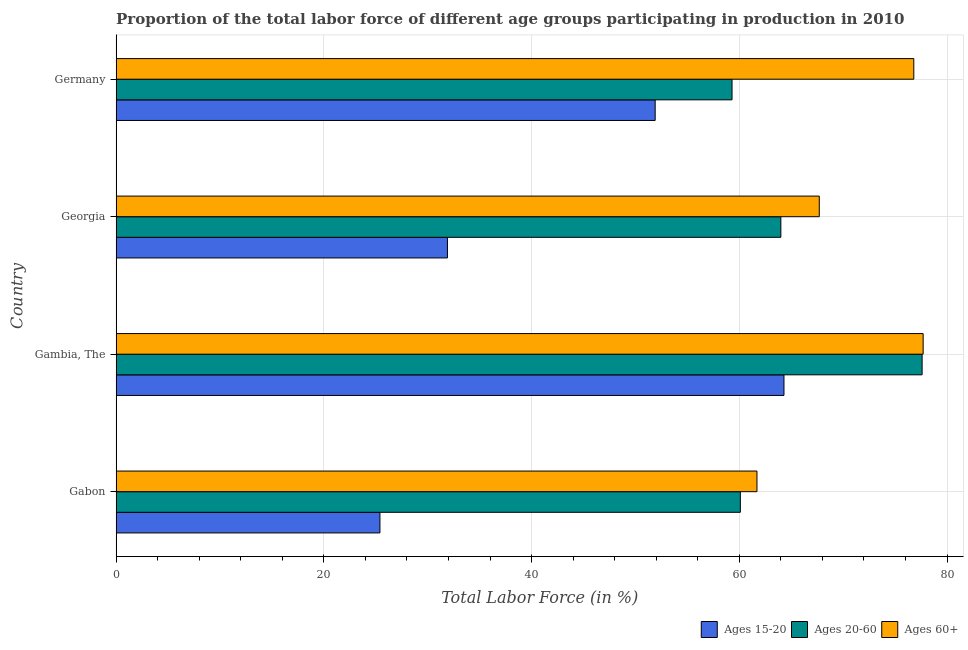How many different coloured bars are there?
Give a very brief answer. 3. How many groups of bars are there?
Keep it short and to the point. 4. Are the number of bars on each tick of the Y-axis equal?
Your answer should be compact. Yes. How many bars are there on the 4th tick from the top?
Give a very brief answer. 3. What is the label of the 2nd group of bars from the top?
Your answer should be very brief. Georgia. What is the percentage of labor force above age 60 in Georgia?
Offer a very short reply. 67.7. Across all countries, what is the maximum percentage of labor force within the age group 20-60?
Make the answer very short. 77.6. Across all countries, what is the minimum percentage of labor force within the age group 20-60?
Your response must be concise. 59.3. In which country was the percentage of labor force within the age group 20-60 maximum?
Your answer should be compact. Gambia, The. What is the total percentage of labor force within the age group 15-20 in the graph?
Your response must be concise. 173.5. What is the difference between the percentage of labor force within the age group 20-60 in Georgia and that in Germany?
Your answer should be very brief. 4.7. What is the difference between the percentage of labor force within the age group 15-20 in Gambia, The and the percentage of labor force within the age group 20-60 in Germany?
Your answer should be very brief. 5. What is the average percentage of labor force within the age group 20-60 per country?
Give a very brief answer. 65.25. What is the difference between the percentage of labor force within the age group 20-60 and percentage of labor force within the age group 15-20 in Georgia?
Keep it short and to the point. 32.1. In how many countries, is the percentage of labor force above age 60 greater than 64 %?
Offer a very short reply. 3. What is the ratio of the percentage of labor force within the age group 20-60 in Gabon to that in Georgia?
Provide a succinct answer. 0.94. Is the percentage of labor force within the age group 15-20 in Gambia, The less than that in Germany?
Provide a short and direct response. No. Is the difference between the percentage of labor force within the age group 15-20 in Gambia, The and Georgia greater than the difference between the percentage of labor force within the age group 20-60 in Gambia, The and Georgia?
Ensure brevity in your answer.  Yes. What is the difference between the highest and the lowest percentage of labor force within the age group 15-20?
Ensure brevity in your answer.  38.9. What does the 1st bar from the top in Germany represents?
Your response must be concise. Ages 60+. What does the 1st bar from the bottom in Gambia, The represents?
Ensure brevity in your answer.  Ages 15-20. Is it the case that in every country, the sum of the percentage of labor force within the age group 15-20 and percentage of labor force within the age group 20-60 is greater than the percentage of labor force above age 60?
Offer a very short reply. Yes. How many bars are there?
Your answer should be very brief. 12. How many countries are there in the graph?
Offer a very short reply. 4. Are the values on the major ticks of X-axis written in scientific E-notation?
Your answer should be compact. No. Does the graph contain any zero values?
Give a very brief answer. No. Does the graph contain grids?
Offer a terse response. Yes. How are the legend labels stacked?
Give a very brief answer. Horizontal. What is the title of the graph?
Provide a succinct answer. Proportion of the total labor force of different age groups participating in production in 2010. Does "Travel services" appear as one of the legend labels in the graph?
Ensure brevity in your answer.  No. What is the label or title of the Y-axis?
Offer a terse response. Country. What is the Total Labor Force (in %) of Ages 15-20 in Gabon?
Ensure brevity in your answer.  25.4. What is the Total Labor Force (in %) in Ages 20-60 in Gabon?
Your response must be concise. 60.1. What is the Total Labor Force (in %) of Ages 60+ in Gabon?
Your response must be concise. 61.7. What is the Total Labor Force (in %) in Ages 15-20 in Gambia, The?
Offer a terse response. 64.3. What is the Total Labor Force (in %) in Ages 20-60 in Gambia, The?
Your answer should be very brief. 77.6. What is the Total Labor Force (in %) of Ages 60+ in Gambia, The?
Provide a succinct answer. 77.7. What is the Total Labor Force (in %) of Ages 15-20 in Georgia?
Your response must be concise. 31.9. What is the Total Labor Force (in %) in Ages 60+ in Georgia?
Provide a short and direct response. 67.7. What is the Total Labor Force (in %) of Ages 15-20 in Germany?
Provide a succinct answer. 51.9. What is the Total Labor Force (in %) of Ages 20-60 in Germany?
Give a very brief answer. 59.3. What is the Total Labor Force (in %) in Ages 60+ in Germany?
Ensure brevity in your answer.  76.8. Across all countries, what is the maximum Total Labor Force (in %) of Ages 15-20?
Ensure brevity in your answer.  64.3. Across all countries, what is the maximum Total Labor Force (in %) of Ages 20-60?
Provide a short and direct response. 77.6. Across all countries, what is the maximum Total Labor Force (in %) in Ages 60+?
Provide a short and direct response. 77.7. Across all countries, what is the minimum Total Labor Force (in %) in Ages 15-20?
Provide a short and direct response. 25.4. Across all countries, what is the minimum Total Labor Force (in %) in Ages 20-60?
Your answer should be very brief. 59.3. Across all countries, what is the minimum Total Labor Force (in %) in Ages 60+?
Your response must be concise. 61.7. What is the total Total Labor Force (in %) of Ages 15-20 in the graph?
Give a very brief answer. 173.5. What is the total Total Labor Force (in %) in Ages 20-60 in the graph?
Keep it short and to the point. 261. What is the total Total Labor Force (in %) of Ages 60+ in the graph?
Offer a very short reply. 283.9. What is the difference between the Total Labor Force (in %) in Ages 15-20 in Gabon and that in Gambia, The?
Offer a terse response. -38.9. What is the difference between the Total Labor Force (in %) in Ages 20-60 in Gabon and that in Gambia, The?
Offer a very short reply. -17.5. What is the difference between the Total Labor Force (in %) of Ages 15-20 in Gabon and that in Georgia?
Give a very brief answer. -6.5. What is the difference between the Total Labor Force (in %) in Ages 60+ in Gabon and that in Georgia?
Keep it short and to the point. -6. What is the difference between the Total Labor Force (in %) in Ages 15-20 in Gabon and that in Germany?
Your answer should be compact. -26.5. What is the difference between the Total Labor Force (in %) of Ages 20-60 in Gabon and that in Germany?
Your answer should be compact. 0.8. What is the difference between the Total Labor Force (in %) in Ages 60+ in Gabon and that in Germany?
Give a very brief answer. -15.1. What is the difference between the Total Labor Force (in %) of Ages 15-20 in Gambia, The and that in Georgia?
Give a very brief answer. 32.4. What is the difference between the Total Labor Force (in %) in Ages 20-60 in Gambia, The and that in Georgia?
Make the answer very short. 13.6. What is the difference between the Total Labor Force (in %) of Ages 20-60 in Gambia, The and that in Germany?
Provide a short and direct response. 18.3. What is the difference between the Total Labor Force (in %) in Ages 20-60 in Georgia and that in Germany?
Provide a succinct answer. 4.7. What is the difference between the Total Labor Force (in %) of Ages 60+ in Georgia and that in Germany?
Give a very brief answer. -9.1. What is the difference between the Total Labor Force (in %) of Ages 15-20 in Gabon and the Total Labor Force (in %) of Ages 20-60 in Gambia, The?
Give a very brief answer. -52.2. What is the difference between the Total Labor Force (in %) in Ages 15-20 in Gabon and the Total Labor Force (in %) in Ages 60+ in Gambia, The?
Your answer should be compact. -52.3. What is the difference between the Total Labor Force (in %) in Ages 20-60 in Gabon and the Total Labor Force (in %) in Ages 60+ in Gambia, The?
Keep it short and to the point. -17.6. What is the difference between the Total Labor Force (in %) in Ages 15-20 in Gabon and the Total Labor Force (in %) in Ages 20-60 in Georgia?
Your answer should be very brief. -38.6. What is the difference between the Total Labor Force (in %) of Ages 15-20 in Gabon and the Total Labor Force (in %) of Ages 60+ in Georgia?
Make the answer very short. -42.3. What is the difference between the Total Labor Force (in %) of Ages 20-60 in Gabon and the Total Labor Force (in %) of Ages 60+ in Georgia?
Give a very brief answer. -7.6. What is the difference between the Total Labor Force (in %) in Ages 15-20 in Gabon and the Total Labor Force (in %) in Ages 20-60 in Germany?
Give a very brief answer. -33.9. What is the difference between the Total Labor Force (in %) in Ages 15-20 in Gabon and the Total Labor Force (in %) in Ages 60+ in Germany?
Provide a succinct answer. -51.4. What is the difference between the Total Labor Force (in %) in Ages 20-60 in Gabon and the Total Labor Force (in %) in Ages 60+ in Germany?
Give a very brief answer. -16.7. What is the difference between the Total Labor Force (in %) in Ages 15-20 in Gambia, The and the Total Labor Force (in %) in Ages 60+ in Germany?
Your response must be concise. -12.5. What is the difference between the Total Labor Force (in %) of Ages 15-20 in Georgia and the Total Labor Force (in %) of Ages 20-60 in Germany?
Offer a terse response. -27.4. What is the difference between the Total Labor Force (in %) of Ages 15-20 in Georgia and the Total Labor Force (in %) of Ages 60+ in Germany?
Provide a short and direct response. -44.9. What is the difference between the Total Labor Force (in %) of Ages 20-60 in Georgia and the Total Labor Force (in %) of Ages 60+ in Germany?
Your answer should be very brief. -12.8. What is the average Total Labor Force (in %) in Ages 15-20 per country?
Your answer should be compact. 43.38. What is the average Total Labor Force (in %) in Ages 20-60 per country?
Ensure brevity in your answer.  65.25. What is the average Total Labor Force (in %) of Ages 60+ per country?
Make the answer very short. 70.97. What is the difference between the Total Labor Force (in %) of Ages 15-20 and Total Labor Force (in %) of Ages 20-60 in Gabon?
Your answer should be compact. -34.7. What is the difference between the Total Labor Force (in %) in Ages 15-20 and Total Labor Force (in %) in Ages 60+ in Gabon?
Ensure brevity in your answer.  -36.3. What is the difference between the Total Labor Force (in %) in Ages 15-20 and Total Labor Force (in %) in Ages 20-60 in Gambia, The?
Provide a succinct answer. -13.3. What is the difference between the Total Labor Force (in %) of Ages 15-20 and Total Labor Force (in %) of Ages 60+ in Gambia, The?
Give a very brief answer. -13.4. What is the difference between the Total Labor Force (in %) in Ages 20-60 and Total Labor Force (in %) in Ages 60+ in Gambia, The?
Your answer should be compact. -0.1. What is the difference between the Total Labor Force (in %) in Ages 15-20 and Total Labor Force (in %) in Ages 20-60 in Georgia?
Your answer should be very brief. -32.1. What is the difference between the Total Labor Force (in %) of Ages 15-20 and Total Labor Force (in %) of Ages 60+ in Georgia?
Offer a very short reply. -35.8. What is the difference between the Total Labor Force (in %) in Ages 15-20 and Total Labor Force (in %) in Ages 60+ in Germany?
Keep it short and to the point. -24.9. What is the difference between the Total Labor Force (in %) of Ages 20-60 and Total Labor Force (in %) of Ages 60+ in Germany?
Ensure brevity in your answer.  -17.5. What is the ratio of the Total Labor Force (in %) of Ages 15-20 in Gabon to that in Gambia, The?
Make the answer very short. 0.4. What is the ratio of the Total Labor Force (in %) in Ages 20-60 in Gabon to that in Gambia, The?
Offer a very short reply. 0.77. What is the ratio of the Total Labor Force (in %) in Ages 60+ in Gabon to that in Gambia, The?
Give a very brief answer. 0.79. What is the ratio of the Total Labor Force (in %) in Ages 15-20 in Gabon to that in Georgia?
Your answer should be very brief. 0.8. What is the ratio of the Total Labor Force (in %) of Ages 20-60 in Gabon to that in Georgia?
Ensure brevity in your answer.  0.94. What is the ratio of the Total Labor Force (in %) of Ages 60+ in Gabon to that in Georgia?
Ensure brevity in your answer.  0.91. What is the ratio of the Total Labor Force (in %) in Ages 15-20 in Gabon to that in Germany?
Give a very brief answer. 0.49. What is the ratio of the Total Labor Force (in %) of Ages 20-60 in Gabon to that in Germany?
Provide a short and direct response. 1.01. What is the ratio of the Total Labor Force (in %) of Ages 60+ in Gabon to that in Germany?
Make the answer very short. 0.8. What is the ratio of the Total Labor Force (in %) in Ages 15-20 in Gambia, The to that in Georgia?
Make the answer very short. 2.02. What is the ratio of the Total Labor Force (in %) in Ages 20-60 in Gambia, The to that in Georgia?
Your response must be concise. 1.21. What is the ratio of the Total Labor Force (in %) in Ages 60+ in Gambia, The to that in Georgia?
Offer a very short reply. 1.15. What is the ratio of the Total Labor Force (in %) in Ages 15-20 in Gambia, The to that in Germany?
Offer a very short reply. 1.24. What is the ratio of the Total Labor Force (in %) in Ages 20-60 in Gambia, The to that in Germany?
Offer a very short reply. 1.31. What is the ratio of the Total Labor Force (in %) of Ages 60+ in Gambia, The to that in Germany?
Provide a succinct answer. 1.01. What is the ratio of the Total Labor Force (in %) in Ages 15-20 in Georgia to that in Germany?
Provide a short and direct response. 0.61. What is the ratio of the Total Labor Force (in %) in Ages 20-60 in Georgia to that in Germany?
Offer a terse response. 1.08. What is the ratio of the Total Labor Force (in %) in Ages 60+ in Georgia to that in Germany?
Your answer should be compact. 0.88. What is the difference between the highest and the second highest Total Labor Force (in %) in Ages 20-60?
Give a very brief answer. 13.6. What is the difference between the highest and the second highest Total Labor Force (in %) of Ages 60+?
Give a very brief answer. 0.9. What is the difference between the highest and the lowest Total Labor Force (in %) in Ages 15-20?
Offer a very short reply. 38.9. 